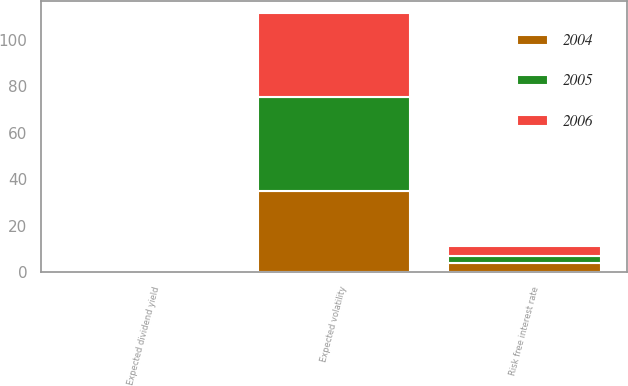Convert chart. <chart><loc_0><loc_0><loc_500><loc_500><stacked_bar_chart><ecel><fcel>Risk free interest rate<fcel>Expected volatility<fcel>Expected dividend yield<nl><fcel>2004<fcel>4.01<fcel>35.1<fcel>0<nl><fcel>2006<fcel>4.25<fcel>35.8<fcel>0<nl><fcel>2005<fcel>3.01<fcel>40.4<fcel>0<nl></chart> 